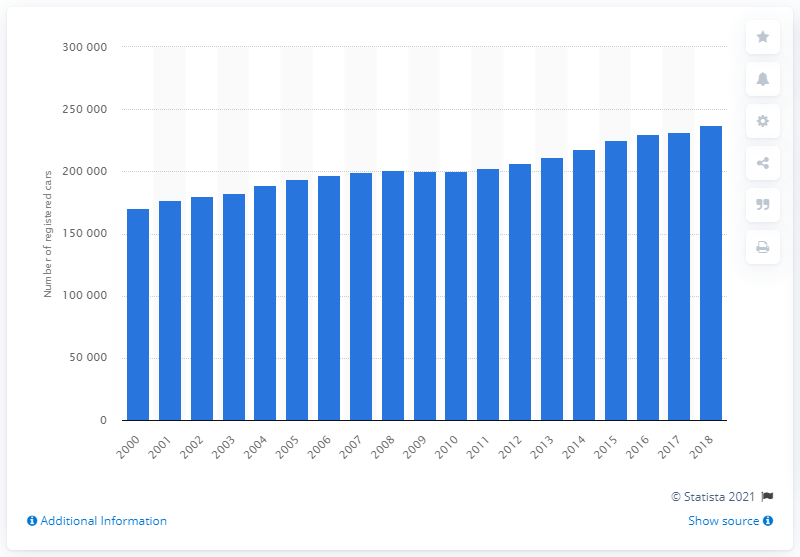Can you speculate on how vehicle technology changes might reflect on this chart? Advances in vehicle technology, like the rise of hybrid and electric vehicles, and improvements in fuel efficiency, may be correlated with registration numbers. The chart may reflect an increasing consumer shift towards more environmentally friendly vehicles, especially in the latter years post-2010, which could explain some of the plateau in registrations as consumers may be holding off purchasing until more advanced models are released.  How might government policies have an effect on the trends we see here? Government policies, including incentives for low-emission vehicles, congestion charges, and changes in road tax, can significantly influence car registration trends. For instance, a subsidy for electric vehicles or increased taxes on diesel cars could either spur or deter new registrations, respectively, which might be reflected as shifts or changes in the overall trend on this chart. 